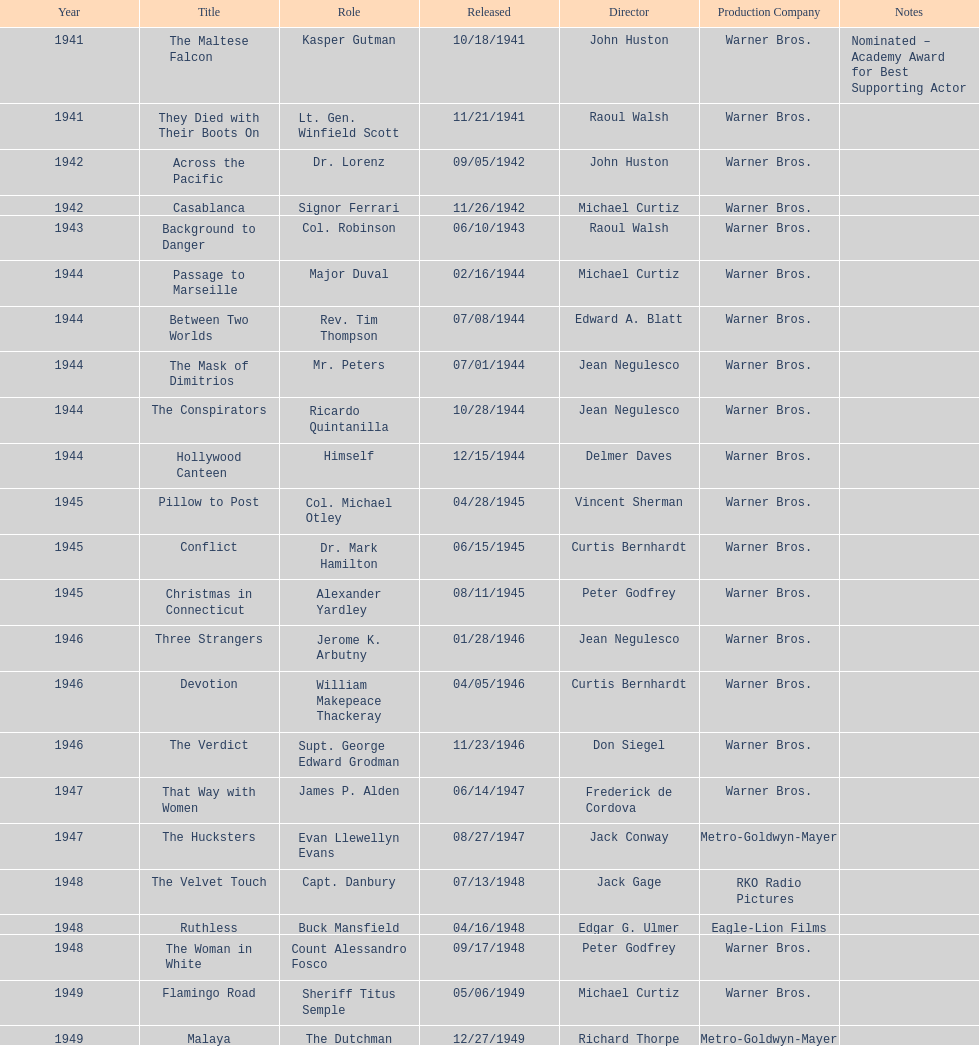What were the opening and closing films greenstreet starred in? The Maltese Falcon, Malaya. 